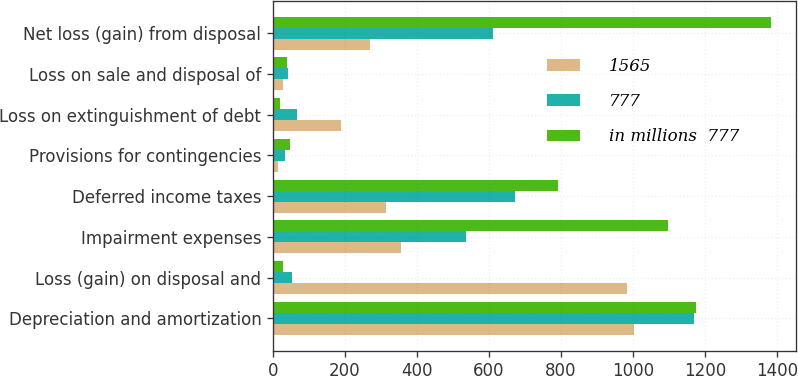Convert chart. <chart><loc_0><loc_0><loc_500><loc_500><stacked_bar_chart><ecel><fcel>Depreciation and amortization<fcel>Loss (gain) on disposal and<fcel>Impairment expenses<fcel>Deferred income taxes<fcel>Provisions for contingencies<fcel>Loss on extinguishment of debt<fcel>Loss on sale and disposal of<fcel>Net loss (gain) from disposal<nl><fcel>1565<fcel>1003<fcel>984<fcel>355<fcel>313<fcel>14<fcel>188<fcel>27<fcel>269<nl><fcel>777<fcel>1169<fcel>52<fcel>537<fcel>672<fcel>34<fcel>68<fcel>43<fcel>611<nl><fcel>in millions  777<fcel>1176<fcel>29<fcel>1098<fcel>793<fcel>48<fcel>20<fcel>38<fcel>1383<nl></chart> 